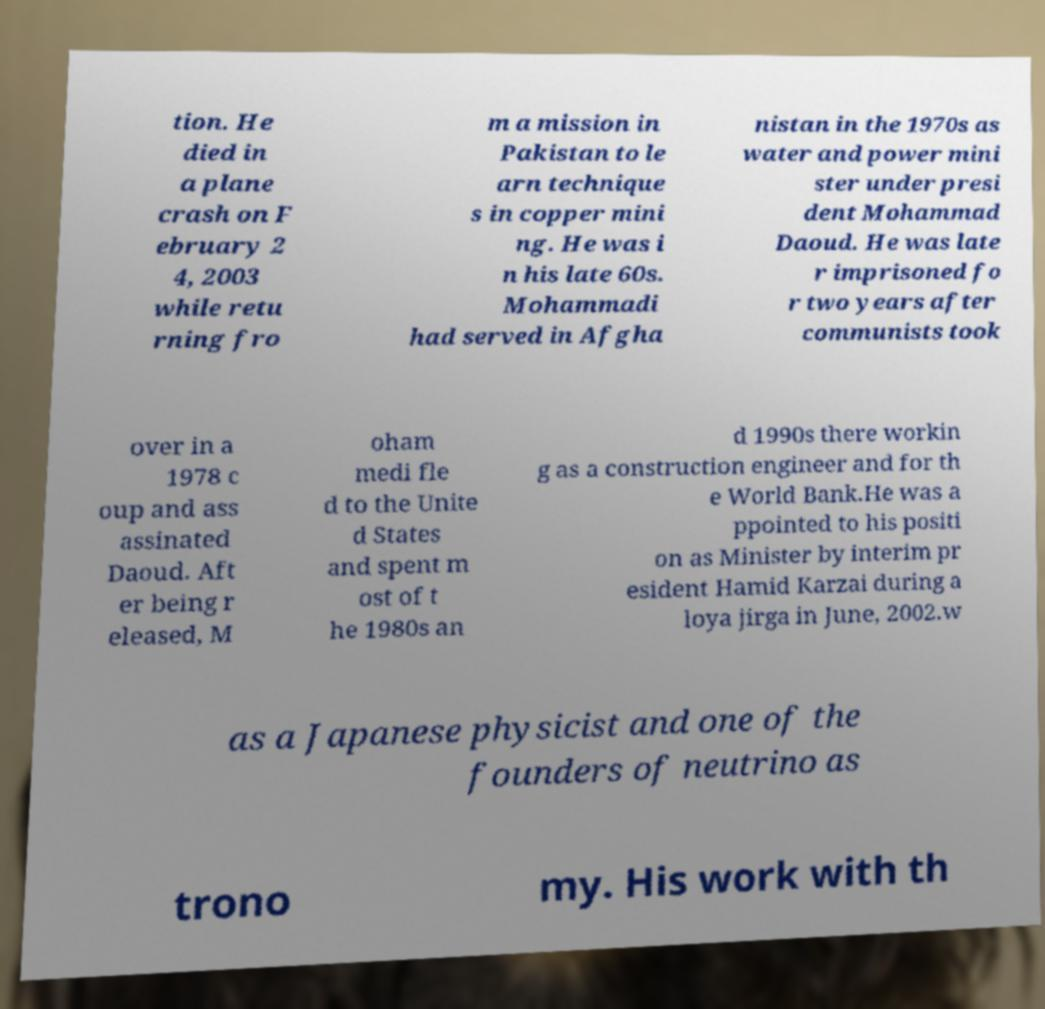Please identify and transcribe the text found in this image. tion. He died in a plane crash on F ebruary 2 4, 2003 while retu rning fro m a mission in Pakistan to le arn technique s in copper mini ng. He was i n his late 60s. Mohammadi had served in Afgha nistan in the 1970s as water and power mini ster under presi dent Mohammad Daoud. He was late r imprisoned fo r two years after communists took over in a 1978 c oup and ass assinated Daoud. Aft er being r eleased, M oham medi fle d to the Unite d States and spent m ost of t he 1980s an d 1990s there workin g as a construction engineer and for th e World Bank.He was a ppointed to his positi on as Minister by interim pr esident Hamid Karzai during a loya jirga in June, 2002.w as a Japanese physicist and one of the founders of neutrino as trono my. His work with th 